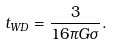<formula> <loc_0><loc_0><loc_500><loc_500>t _ { W D } = \frac { 3 } { 1 6 \pi G \sigma } .</formula> 